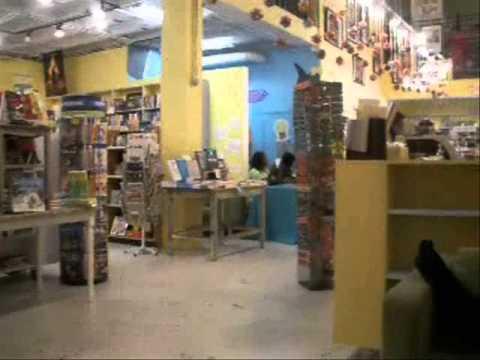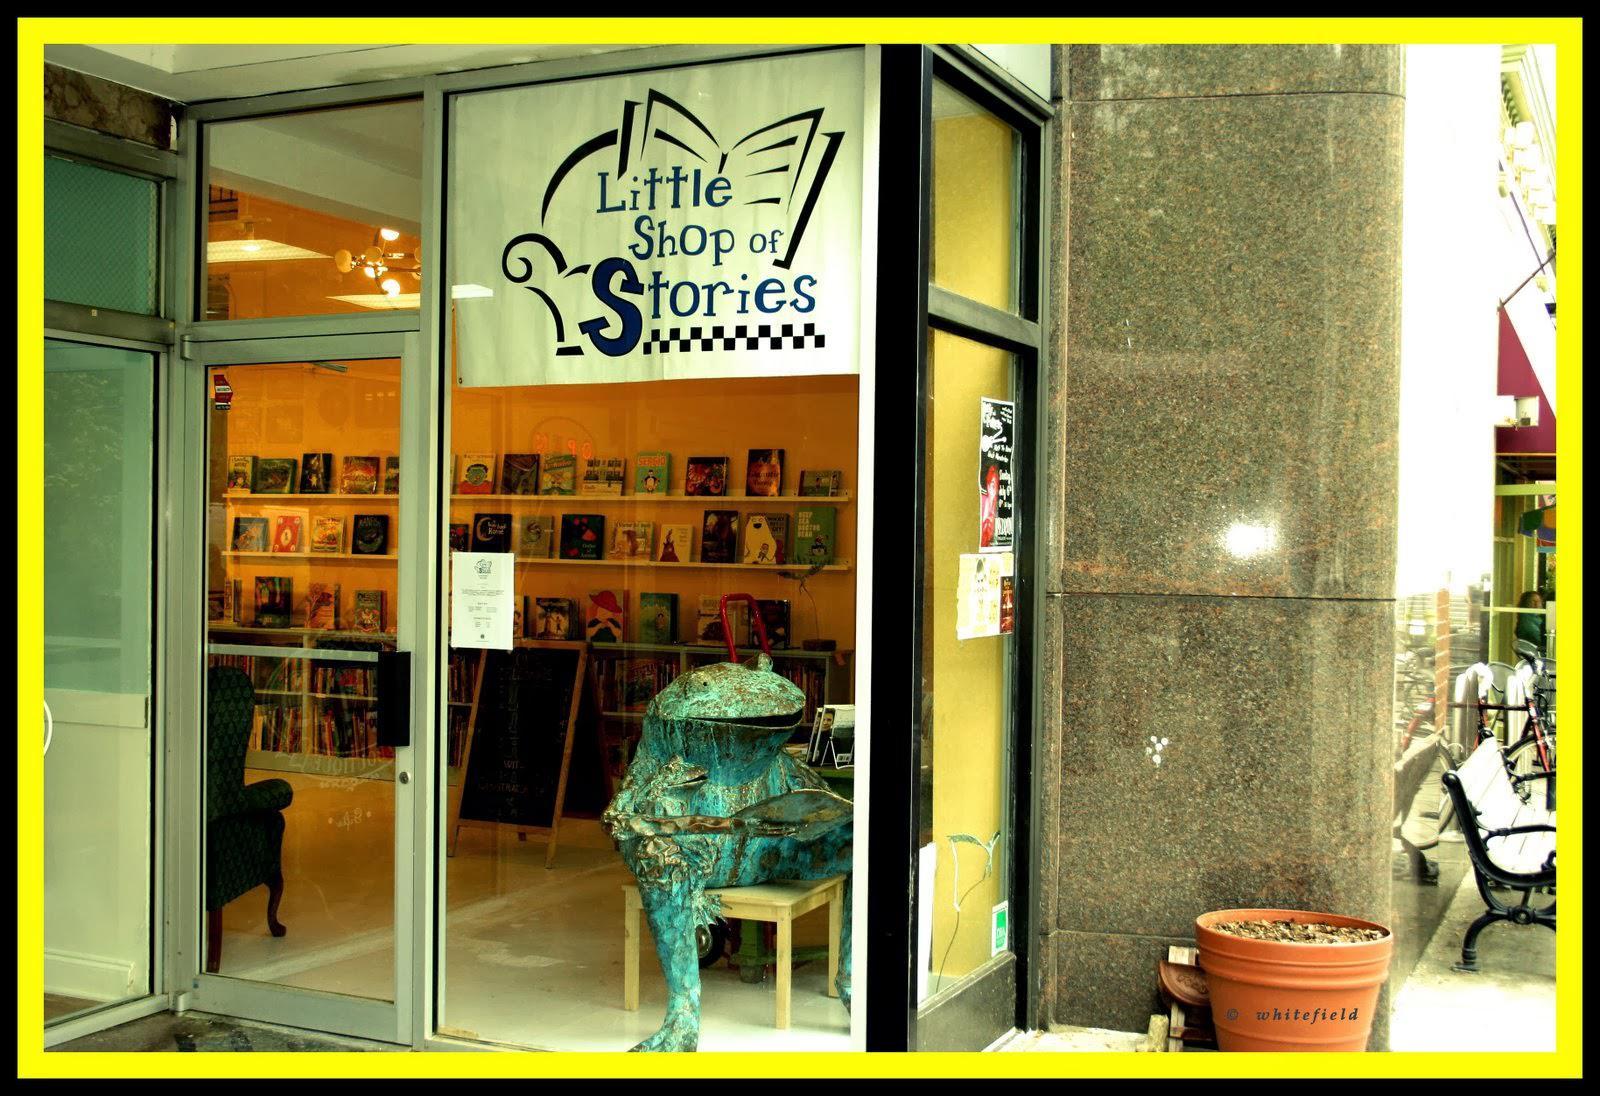The first image is the image on the left, the second image is the image on the right. Analyze the images presented: Is the assertion "In at least one image there is a male child looking at yellow painted walls in the bookstore." valid? Answer yes or no. No. The first image is the image on the left, the second image is the image on the right. Assess this claim about the two images: "One image shows a back-turned person standing in front of shelves at the right of the scene, and the other image includes at least one person sitting with a leg extended on the floor and back to the right.". Correct or not? Answer yes or no. No. 